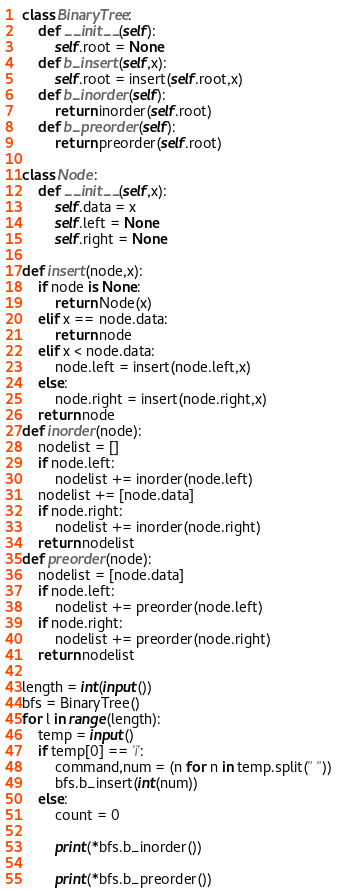<code> <loc_0><loc_0><loc_500><loc_500><_Python_>class BinaryTree:
    def __init__(self):
        self.root = None
    def b_insert(self,x):
        self.root = insert(self.root,x)
    def b_inorder(self):
        return inorder(self.root)
    def b_preorder(self):
        return preorder(self.root)
        
class Node:
    def __init__(self,x):
        self.data = x
        self.left = None
        self.right = None
            
def insert(node,x):
    if node is None:
        return Node(x)
    elif x == node.data:
        return node
    elif x < node.data:
        node.left = insert(node.left,x)
    else:
        node.right = insert(node.right,x)
    return node
def inorder(node):
    nodelist = []
    if node.left:
        nodelist += inorder(node.left)
    nodelist += [node.data]
    if node.right:
        nodelist += inorder(node.right)
    return nodelist
def preorder(node):
    nodelist = [node.data]
    if node.left:
        nodelist += preorder(node.left)
    if node.right:
        nodelist += preorder(node.right)
    return nodelist

length = int(input())
bfs = BinaryTree()
for l in range(length):
    temp = input()
    if temp[0] == 'i':
        command,num = (n for n in temp.split(" "))
        bfs.b_insert(int(num))
    else:
        count = 0
        
        print(*bfs.b_inorder())
        
        print(*bfs.b_preorder())</code> 